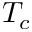Convert formula to latex. <formula><loc_0><loc_0><loc_500><loc_500>T _ { c }</formula> 